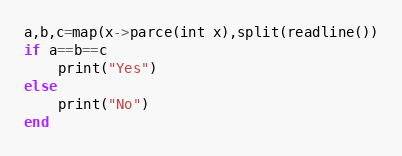<code> <loc_0><loc_0><loc_500><loc_500><_Julia_>a,b,c=map(x->parce(int x),split(readline())
if a==b==c
    print("Yes")
else
    print("No")
end
</code> 